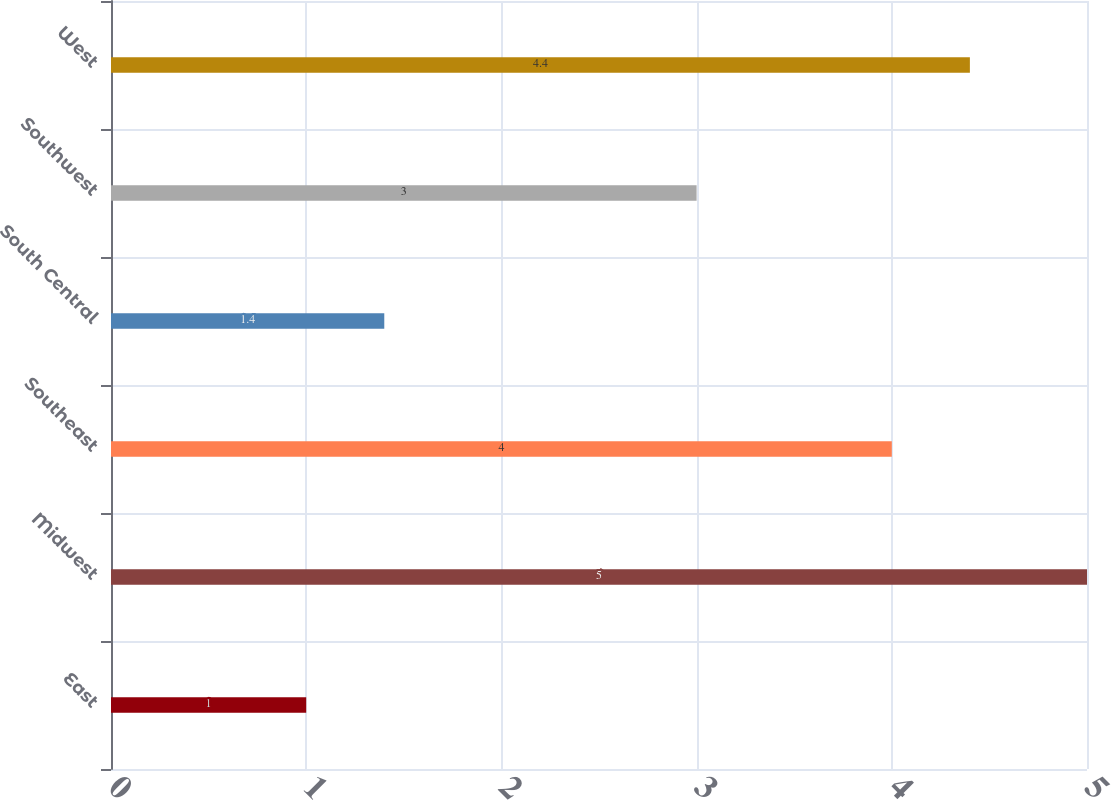Convert chart to OTSL. <chart><loc_0><loc_0><loc_500><loc_500><bar_chart><fcel>East<fcel>Midwest<fcel>Southeast<fcel>South Central<fcel>Southwest<fcel>West<nl><fcel>1<fcel>5<fcel>4<fcel>1.4<fcel>3<fcel>4.4<nl></chart> 